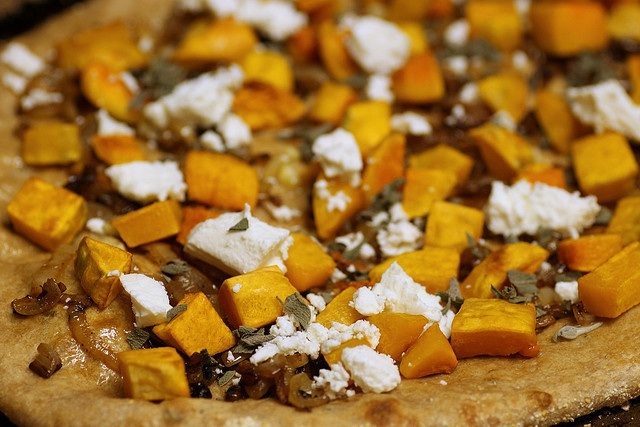Describe the objects in this image and their specific colors. I can see a pizza in olive, maroon, orange, and lightgray tones in this image. 